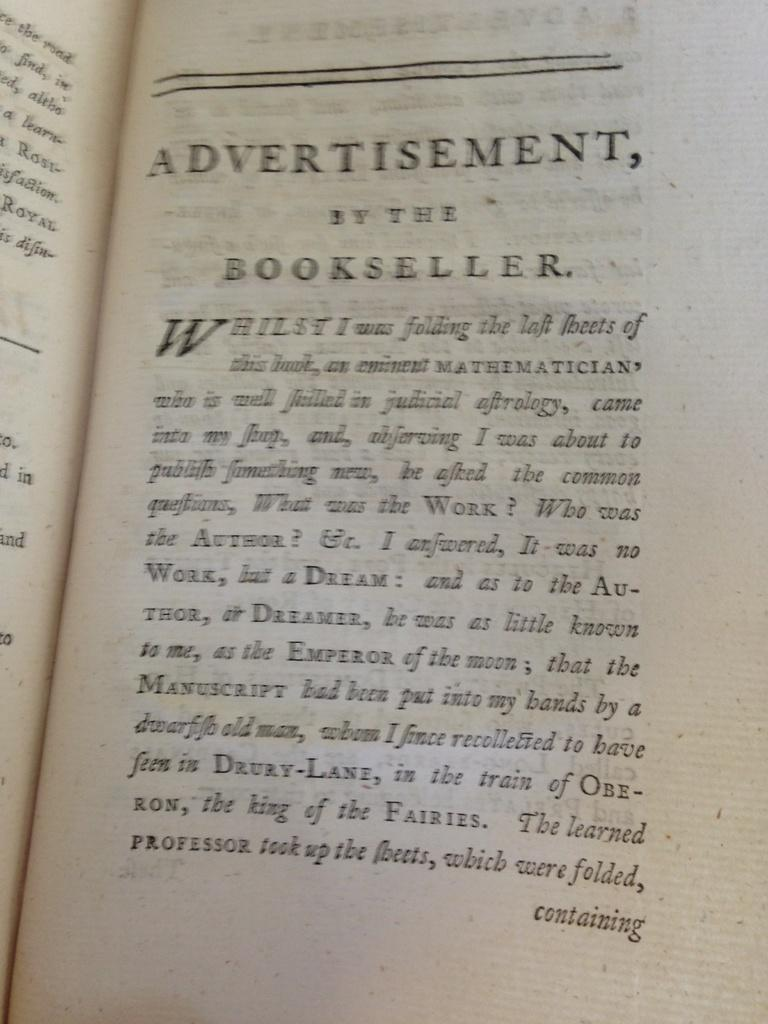What is the main object in the image? There is an open book in the image. What can be found inside the open book? The open book contains text. What type of wire is being used by the wren in the image? There is no wren or wire present in the image; it only features an open book with text. 